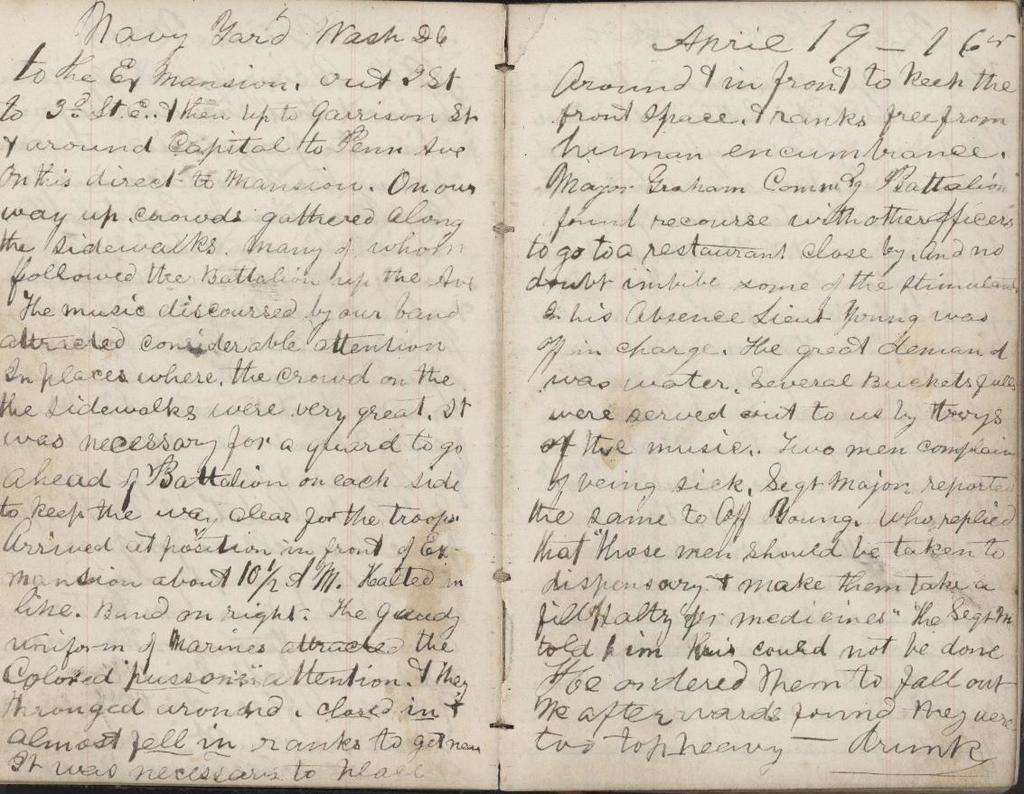<image>
Write a terse but informative summary of the picture. A journal full of writing is open to a page labeled Navy Yard. 